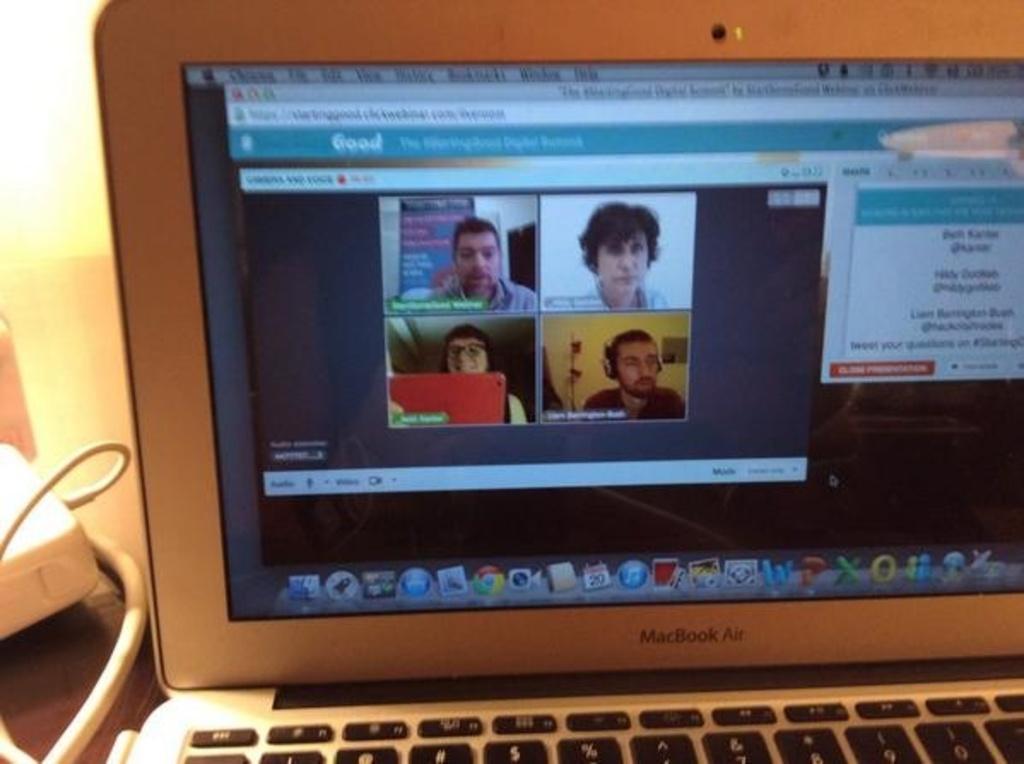Can you describe this image briefly? In this picture I can see a laptop on the table displaying some pictures and text on the screen and I can see charge on the left side. 